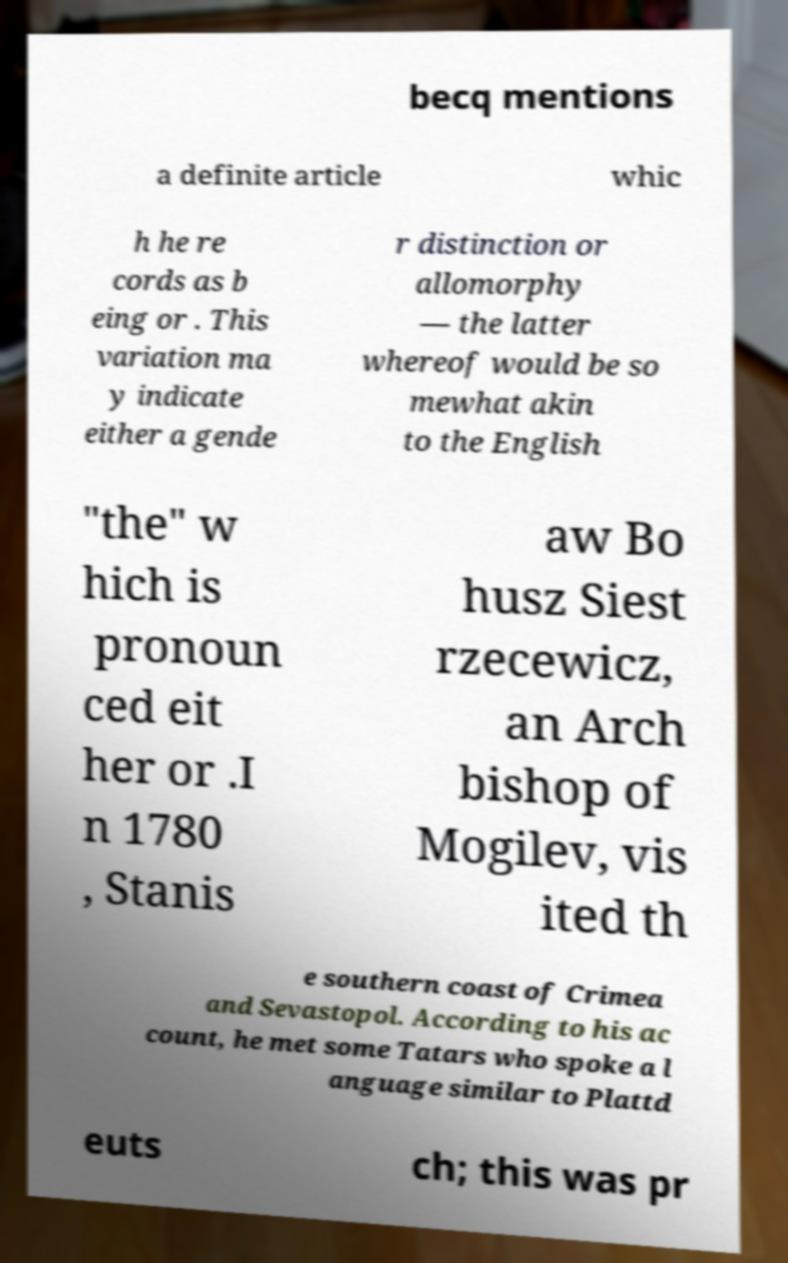Could you extract and type out the text from this image? becq mentions a definite article whic h he re cords as b eing or . This variation ma y indicate either a gende r distinction or allomorphy — the latter whereof would be so mewhat akin to the English "the" w hich is pronoun ced eit her or .I n 1780 , Stanis aw Bo husz Siest rzecewicz, an Arch bishop of Mogilev, vis ited th e southern coast of Crimea and Sevastopol. According to his ac count, he met some Tatars who spoke a l anguage similar to Plattd euts ch; this was pr 